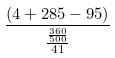<formula> <loc_0><loc_0><loc_500><loc_500>\frac { ( 4 + 2 8 5 - 9 5 ) } { \frac { \frac { 3 6 0 } { 5 0 0 } } { 4 1 } }</formula> 